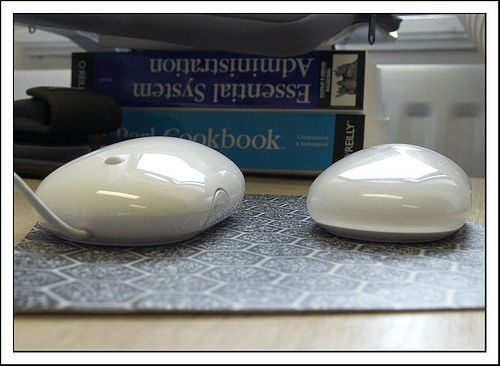Describe the objects in this image and their specific colors. I can see mouse in black, lightgray, darkgray, and gray tones, book in black and gray tones, mouse in black, darkgray, lightgray, and gray tones, and book in black, darkblue, gray, and blue tones in this image. 